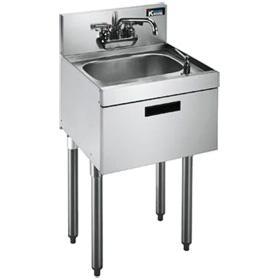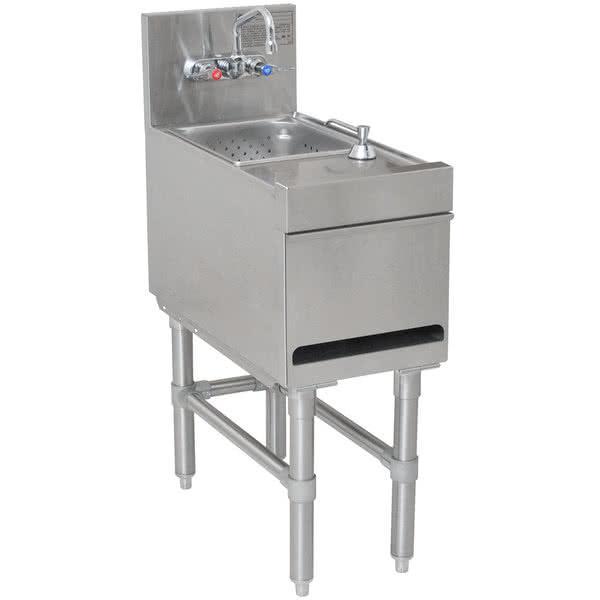The first image is the image on the left, the second image is the image on the right. For the images shown, is this caption "There are two sinks, and none of them have legs." true? Answer yes or no. No. 